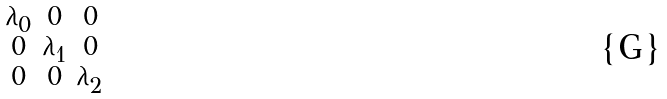<formula> <loc_0><loc_0><loc_500><loc_500>\begin{smallmatrix} \lambda _ { 0 } & 0 & 0 \\ 0 & \lambda _ { 1 } & 0 \\ 0 & 0 & \lambda _ { 2 } \\ \end{smallmatrix}</formula> 